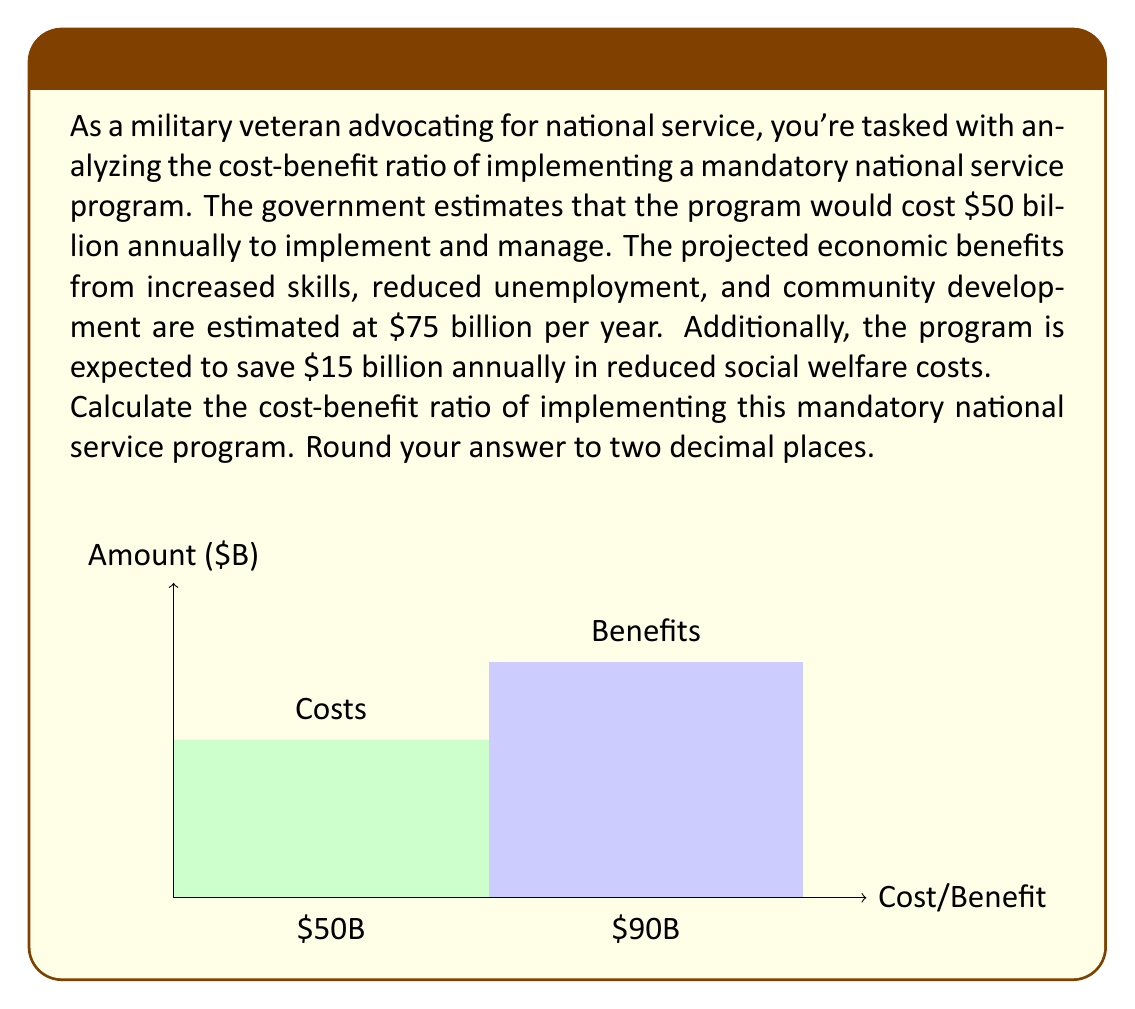Could you help me with this problem? To calculate the cost-benefit ratio, we need to follow these steps:

1) First, let's identify the total costs and benefits:

   Costs = $50 billion (annual implementation and management)
   
   Benefits = $75 billion (economic benefits) + $15 billion (savings in social welfare)
             = $90 billion

2) The cost-benefit ratio is calculated by dividing the total benefits by the total costs:

   Cost-Benefit Ratio = $\frac{\text{Total Benefits}}{\text{Total Costs}}$

3) Let's plug in our values:

   Cost-Benefit Ratio = $\frac{\$90 \text{ billion}}{\$50 \text{ billion}}$

4) Perform the division:

   Cost-Benefit Ratio = $1.8$

5) The question asks to round to two decimal places, but 1.8 is already in that form.

Therefore, the cost-benefit ratio of implementing this mandatory national service program is 1.8.

Interpretation: A ratio greater than 1 indicates that the benefits outweigh the costs. In this case, for every dollar spent on the program, the nation receives $1.80 in benefits.
Answer: 1.80 